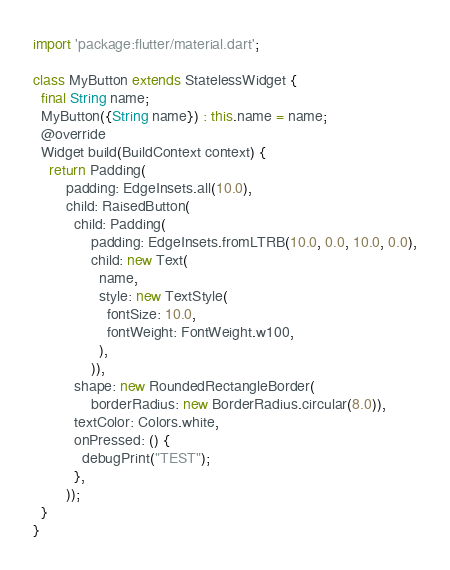<code> <loc_0><loc_0><loc_500><loc_500><_Dart_>import 'package:flutter/material.dart';

class MyButton extends StatelessWidget {
  final String name;
  MyButton({String name}) : this.name = name;
  @override
  Widget build(BuildContext context) {
    return Padding(
        padding: EdgeInsets.all(10.0),
        child: RaisedButton(
          child: Padding(
              padding: EdgeInsets.fromLTRB(10.0, 0.0, 10.0, 0.0),
              child: new Text(
                name,
                style: new TextStyle(
                  fontSize: 10.0,
                  fontWeight: FontWeight.w100,
                ),
              )),
          shape: new RoundedRectangleBorder(
              borderRadius: new BorderRadius.circular(8.0)),
          textColor: Colors.white,
          onPressed: () {
            debugPrint("TEST");
          },
        ));
  }
}
</code> 